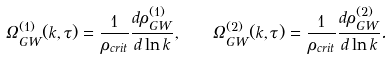Convert formula to latex. <formula><loc_0><loc_0><loc_500><loc_500>\Omega _ { G W } ^ { ( 1 ) } ( k , \tau ) = \frac { 1 } { \rho _ { c r i t } } \frac { d \rho ^ { ( 1 ) } _ { G W } } { d \ln { k } } , \quad \Omega _ { G W } ^ { ( 2 ) } ( k , \tau ) = \frac { 1 } { \rho _ { c r i t } } \frac { d \rho ^ { ( 2 ) } _ { G W } } { d \ln { k } } .</formula> 